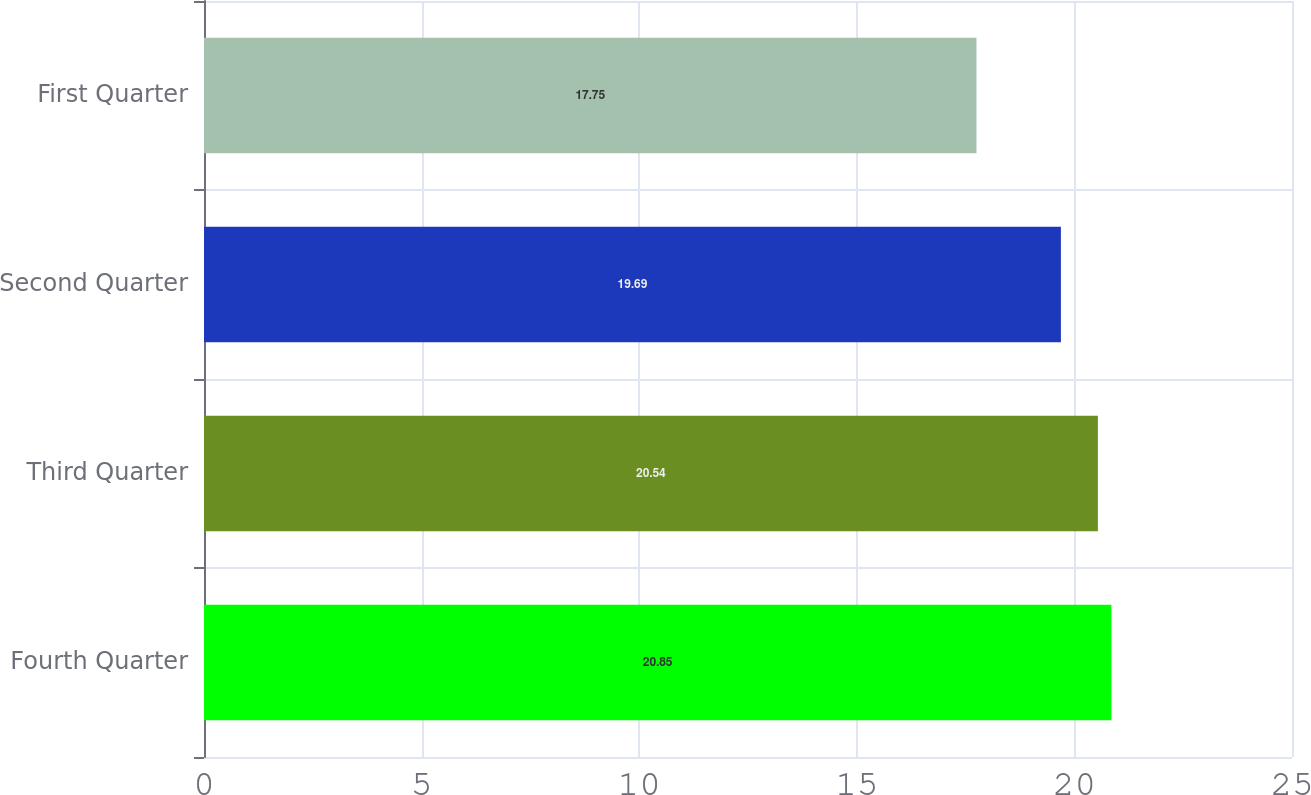Convert chart to OTSL. <chart><loc_0><loc_0><loc_500><loc_500><bar_chart><fcel>Fourth Quarter<fcel>Third Quarter<fcel>Second Quarter<fcel>First Quarter<nl><fcel>20.85<fcel>20.54<fcel>19.69<fcel>17.75<nl></chart> 